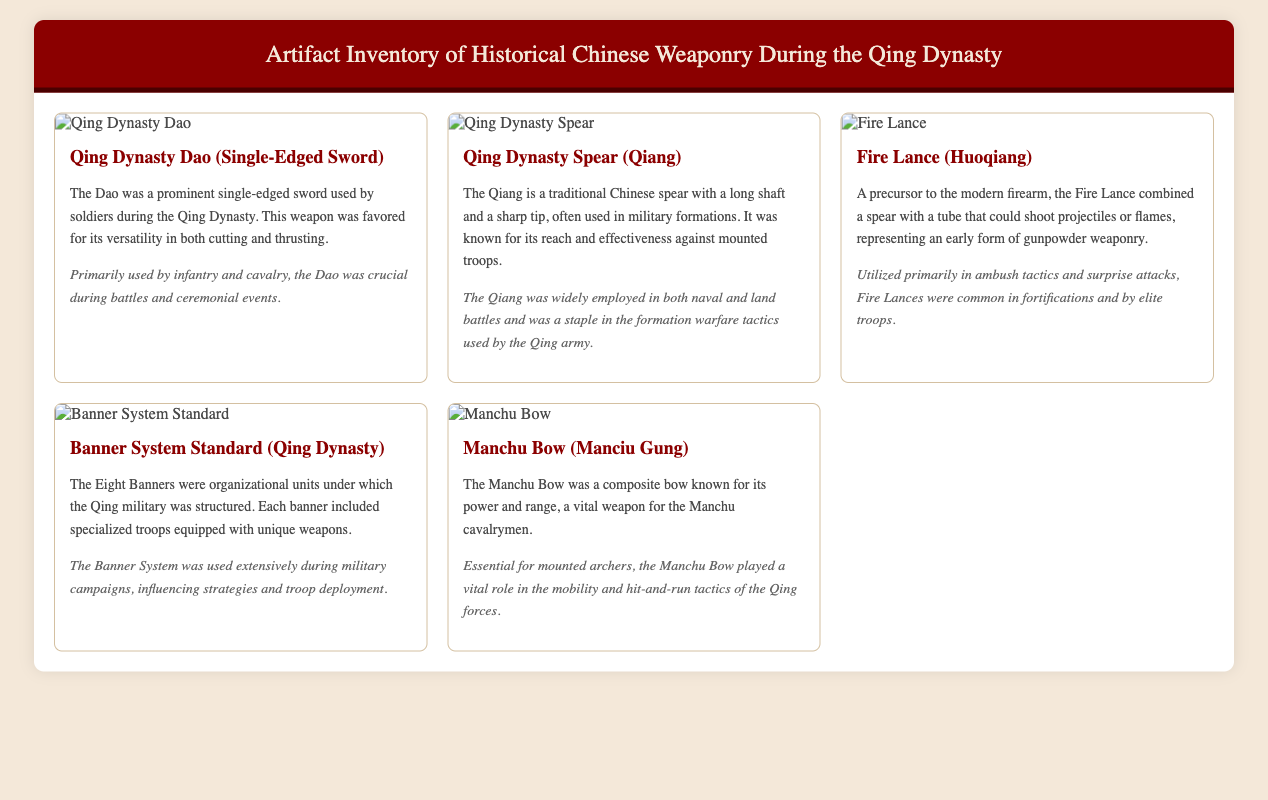What is the primary weapon used by infantry and cavalry in the Qing Dynasty? The primary weapon used by infantry and cavalry during the Qing Dynasty is the Dao, which is a single-edged sword.
Answer: Dao Which weapon is known for its reach and effectiveness against mounted troops? The weapon known for its reach and effectiveness against mounted troops is the Qiang, a traditional Chinese spear.
Answer: Qiang What type of weapon is the Fire Lance? The Fire Lance is a precursor to the modern firearm that combines a spear with a tube for shooting projectiles or flames.
Answer: Gunpowder weapon What organizational system did the Qing military use? The Qing military used the Eight Banners as an organizational system for its troops.
Answer: Eight Banners Which bow was vital for the Manchu cavalrymen? The bow that was vital for the Manchu cavalrymen is the Manchu Bow, known for its power and range.
Answer: Manchu Bow How were the soldiers categorized in the Banner System? Soldiers in the Banner System were categorized into specialized troops, each equipped with unique weapons.
Answer: Specialized troops What context did the Fire Lance primarily serve in? The Fire Lance was primarily used in ambush tactics and surprise attacks.
Answer: Ambush tactics How did the Manchu Bow influence Qing military tactics? The Manchu Bow influenced Qing military tactics by allowing mobility and hit-and-run strategies for mounted archers.
Answer: Mobility and hit-and-run tactics 